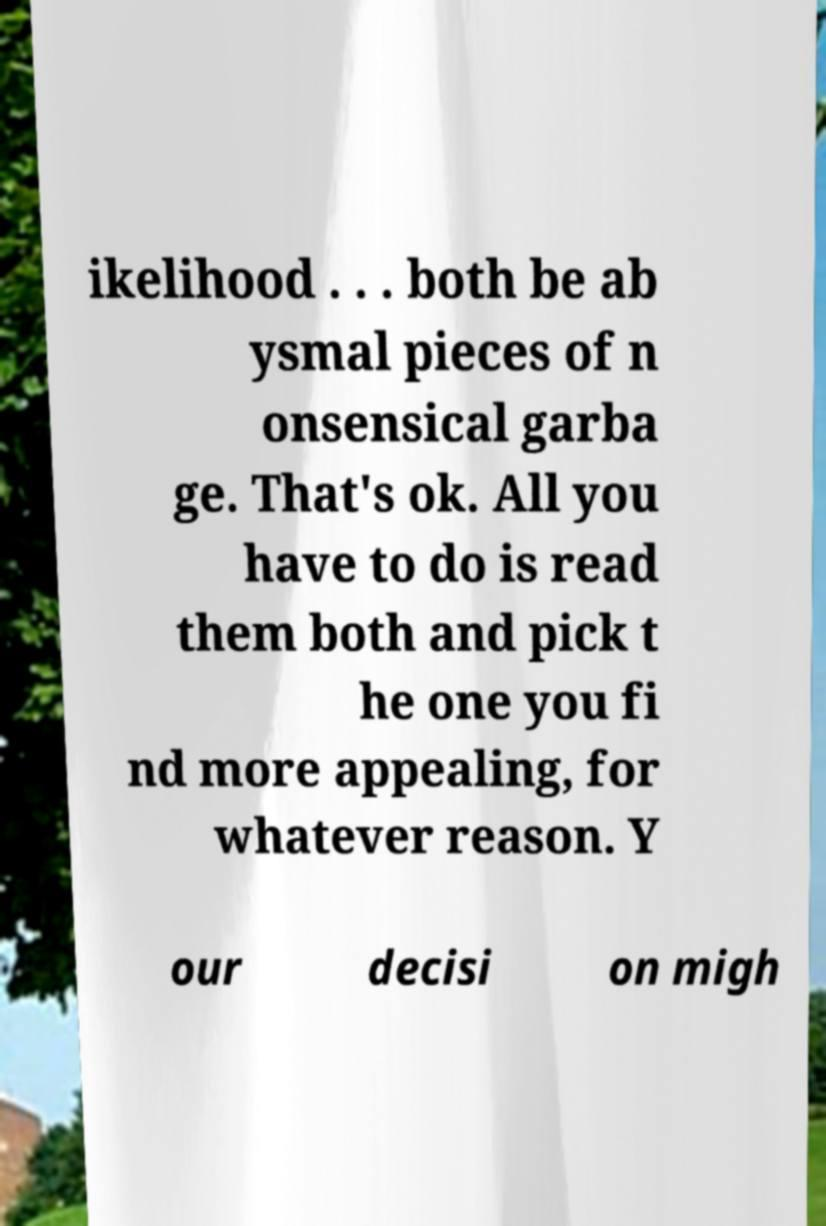Please read and relay the text visible in this image. What does it say? ikelihood . . . both be ab ysmal pieces of n onsensical garba ge. That's ok. All you have to do is read them both and pick t he one you fi nd more appealing, for whatever reason. Y our decisi on migh 